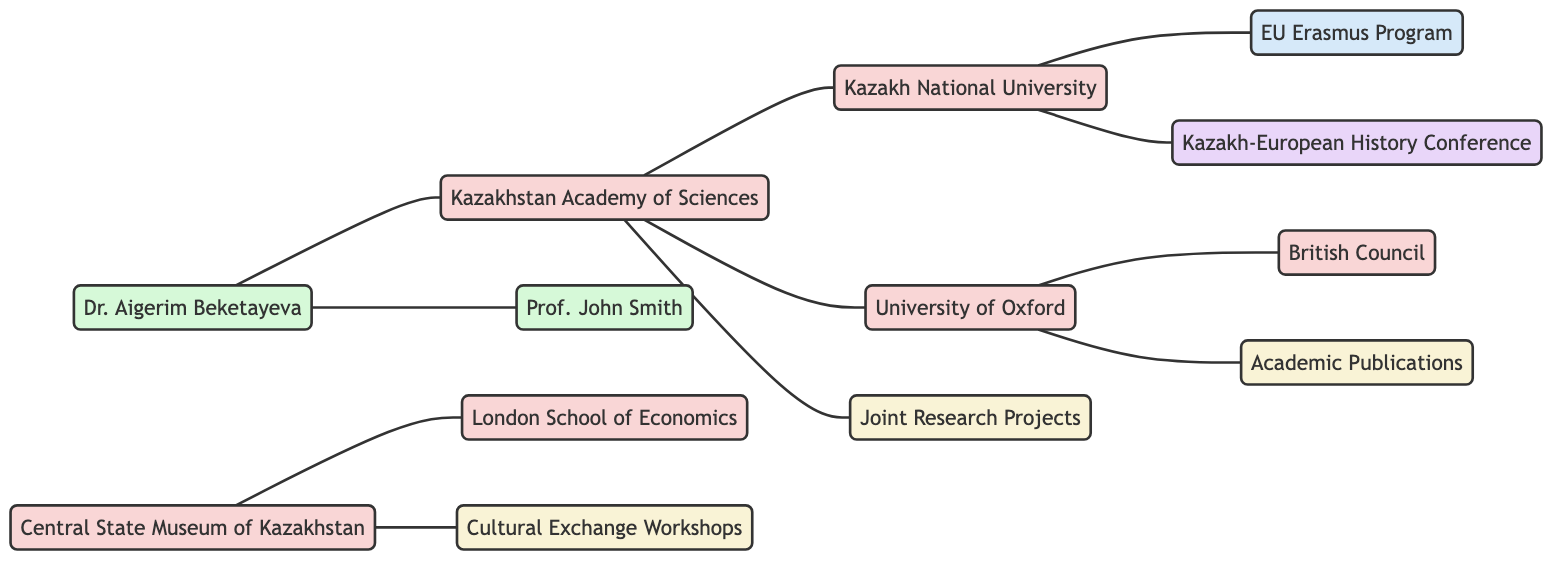What is the total number of institutions in the diagram? The diagram contains the following institutions: Kazakhstan Academy of Sciences, Central State Museum of Kazakhstan, Kazakh National University, University of Oxford, London School of Economics, and British Council. Counting these gives a total of 6 institutions.
Answer: 6 Which institution collaborates with the University of Oxford? The diagram shows a direct link where the University of Oxford is connected to two institutions. The link specifies that it collaborates with Kazakhstan Academy of Sciences.
Answer: Kazakhstan Academy of Sciences How many activities are listed in this diagram? There are three activities in the diagram: Joint Research Projects, Academic Publications, and Cultural Exchange Workshops. These represent distinct types of scholarly engagement. Thus, the total number of activities is 3.
Answer: 3 Who organizes cultural exchange workshops? The Central State Museum of Kazakhstan is directly connected to the Cultural Exchange Workshops in the diagram, indicating it is the institution responsible for organizing these workshops.
Answer: Central State Museum of Kazakhstan What role does Dr. Aigerim Beketayeva play in this network? The diagram identifies Dr. Aigerim Beketayeva as an individual and specifies her role as an anthropologist. There are links that show she is affiliated with the Kazakhstan Academy of Sciences and has a research partnership with Prof. John Smith.
Answer: Anthropologist Which program is associated with the Kazakh National University? Kazakh National University is shown to participate in the EU Erasmus Program, indicating a connection where it engages with this educational exchange initiative.
Answer: EU Erasmus Program What event does Kazakh National University host? The Kazakh-European History Conference is specifically linked to Kazakh National University in the diagram, marking it as the host of this event.
Answer: Kazakh-European History Conference Which institution produces academic publications? The diagram states that the University of Oxford produces academic publications, showing an active role in scholarly output.
Answer: University of Oxford Who is the research partner of Dr. Aigerim Beketayeva? The diagram indicates that Dr. Aigerim Beketayeva collaborates with Prof. John Smith, establishing a research partnership between the two.
Answer: Prof. John Smith 